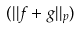Convert formula to latex. <formula><loc_0><loc_0><loc_500><loc_500>( | | f + g | | _ { p } )</formula> 